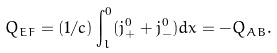<formula> <loc_0><loc_0><loc_500><loc_500>Q _ { E F } = ( 1 / c ) \int _ { l } ^ { 0 } ( j _ { + } ^ { 0 } + j _ { - } ^ { 0 } ) d x = - Q _ { A B } .</formula> 